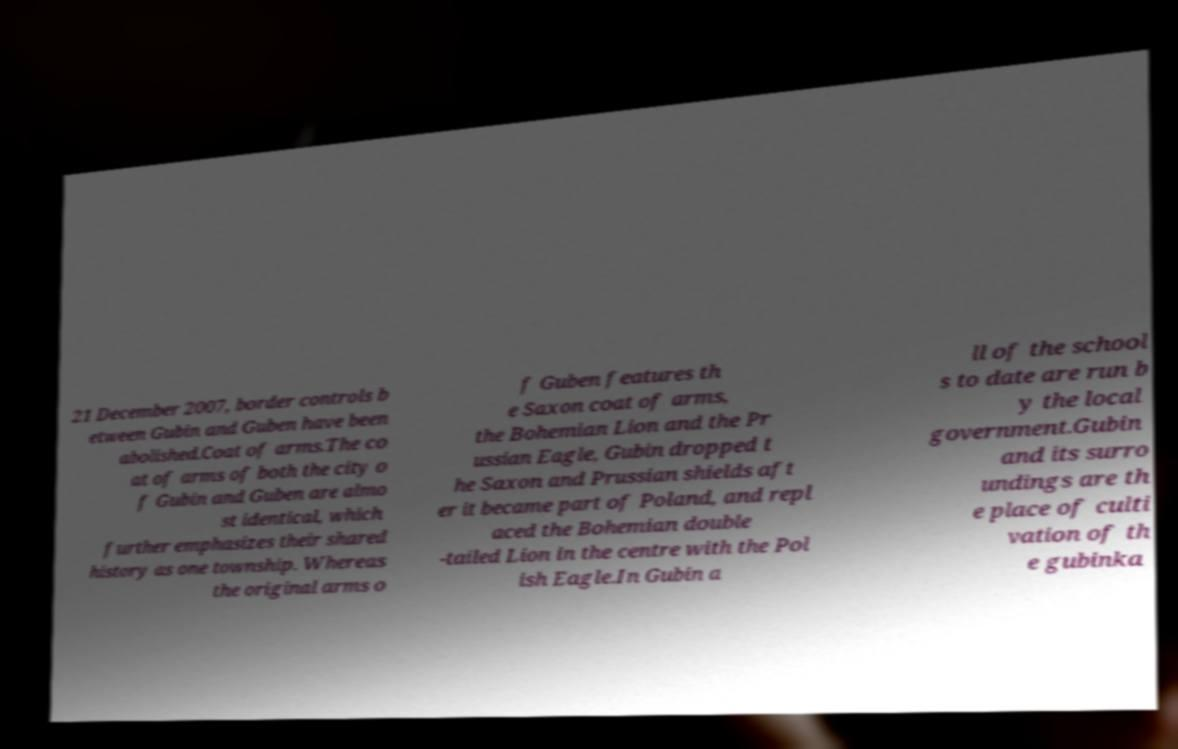Can you read and provide the text displayed in the image?This photo seems to have some interesting text. Can you extract and type it out for me? 21 December 2007, border controls b etween Gubin and Guben have been abolished.Coat of arms.The co at of arms of both the city o f Gubin and Guben are almo st identical, which further emphasizes their shared history as one township. Whereas the original arms o f Guben features th e Saxon coat of arms, the Bohemian Lion and the Pr ussian Eagle, Gubin dropped t he Saxon and Prussian shields aft er it became part of Poland, and repl aced the Bohemian double -tailed Lion in the centre with the Pol ish Eagle.In Gubin a ll of the school s to date are run b y the local government.Gubin and its surro undings are th e place of culti vation of th e gubinka 